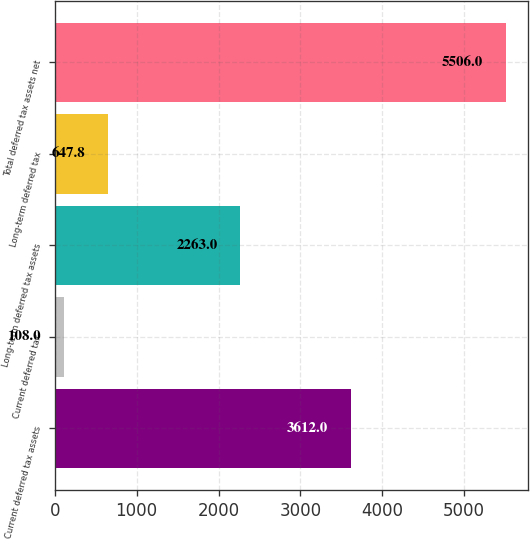<chart> <loc_0><loc_0><loc_500><loc_500><bar_chart><fcel>Current deferred tax assets<fcel>Current deferred tax<fcel>Long-term deferred tax assets<fcel>Long-term deferred tax<fcel>Total deferred tax assets net<nl><fcel>3612<fcel>108<fcel>2263<fcel>647.8<fcel>5506<nl></chart> 